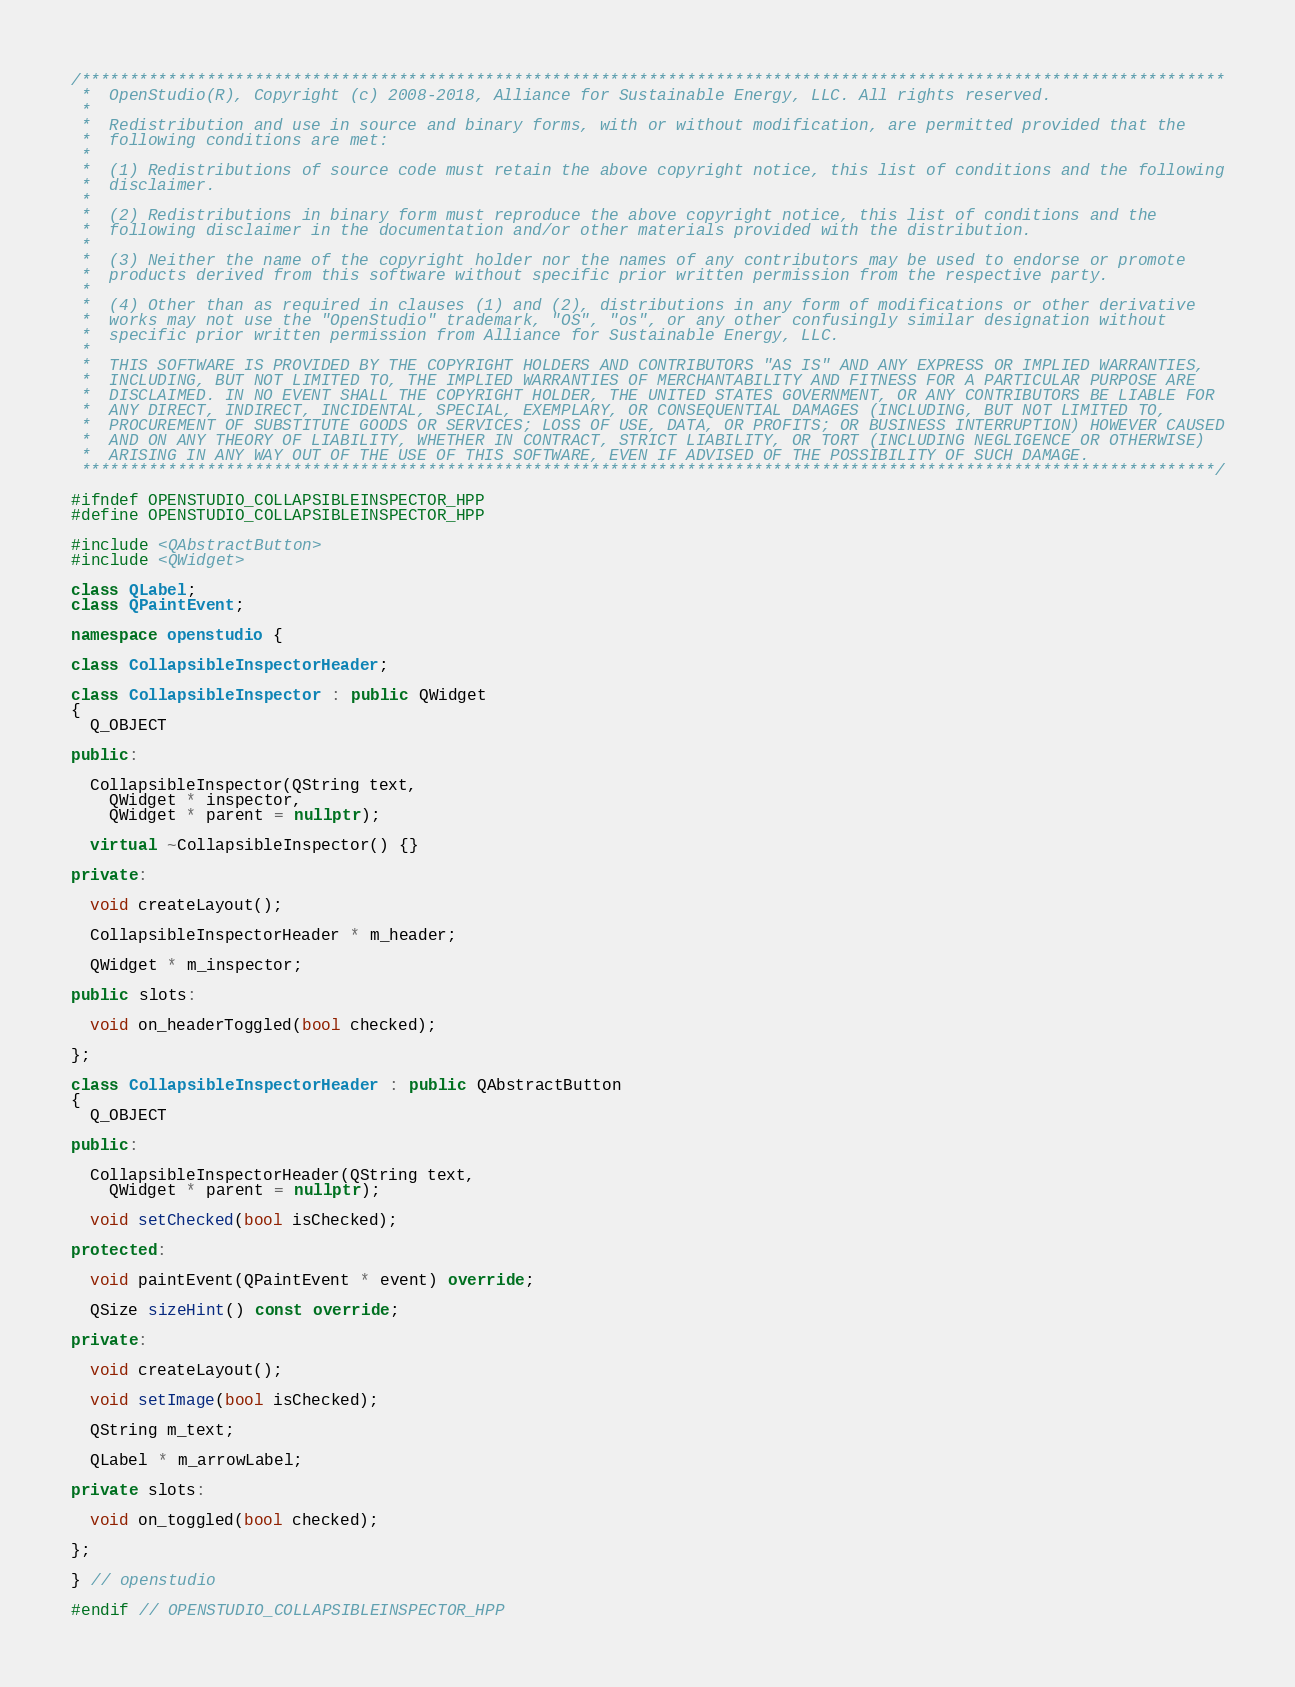<code> <loc_0><loc_0><loc_500><loc_500><_C++_>/***********************************************************************************************************************
 *  OpenStudio(R), Copyright (c) 2008-2018, Alliance for Sustainable Energy, LLC. All rights reserved.
 *
 *  Redistribution and use in source and binary forms, with or without modification, are permitted provided that the
 *  following conditions are met:
 *
 *  (1) Redistributions of source code must retain the above copyright notice, this list of conditions and the following
 *  disclaimer.
 *
 *  (2) Redistributions in binary form must reproduce the above copyright notice, this list of conditions and the
 *  following disclaimer in the documentation and/or other materials provided with the distribution.
 *
 *  (3) Neither the name of the copyright holder nor the names of any contributors may be used to endorse or promote
 *  products derived from this software without specific prior written permission from the respective party.
 *
 *  (4) Other than as required in clauses (1) and (2), distributions in any form of modifications or other derivative
 *  works may not use the "OpenStudio" trademark, "OS", "os", or any other confusingly similar designation without
 *  specific prior written permission from Alliance for Sustainable Energy, LLC.
 *
 *  THIS SOFTWARE IS PROVIDED BY THE COPYRIGHT HOLDERS AND CONTRIBUTORS "AS IS" AND ANY EXPRESS OR IMPLIED WARRANTIES,
 *  INCLUDING, BUT NOT LIMITED TO, THE IMPLIED WARRANTIES OF MERCHANTABILITY AND FITNESS FOR A PARTICULAR PURPOSE ARE
 *  DISCLAIMED. IN NO EVENT SHALL THE COPYRIGHT HOLDER, THE UNITED STATES GOVERNMENT, OR ANY CONTRIBUTORS BE LIABLE FOR
 *  ANY DIRECT, INDIRECT, INCIDENTAL, SPECIAL, EXEMPLARY, OR CONSEQUENTIAL DAMAGES (INCLUDING, BUT NOT LIMITED TO,
 *  PROCUREMENT OF SUBSTITUTE GOODS OR SERVICES; LOSS OF USE, DATA, OR PROFITS; OR BUSINESS INTERRUPTION) HOWEVER CAUSED
 *  AND ON ANY THEORY OF LIABILITY, WHETHER IN CONTRACT, STRICT LIABILITY, OR TORT (INCLUDING NEGLIGENCE OR OTHERWISE)
 *  ARISING IN ANY WAY OUT OF THE USE OF THIS SOFTWARE, EVEN IF ADVISED OF THE POSSIBILITY OF SUCH DAMAGE.
 **********************************************************************************************************************/

#ifndef OPENSTUDIO_COLLAPSIBLEINSPECTOR_HPP
#define OPENSTUDIO_COLLAPSIBLEINSPECTOR_HPP

#include <QAbstractButton>
#include <QWidget>

class QLabel;
class QPaintEvent;

namespace openstudio {

class CollapsibleInspectorHeader;

class CollapsibleInspector : public QWidget
{
  Q_OBJECT

public:

  CollapsibleInspector(QString text,
    QWidget * inspector,
    QWidget * parent = nullptr);

  virtual ~CollapsibleInspector() {}

private:

  void createLayout();

  CollapsibleInspectorHeader * m_header;

  QWidget * m_inspector;

public slots:

  void on_headerToggled(bool checked);

};

class CollapsibleInspectorHeader : public QAbstractButton
{
  Q_OBJECT

public:

  CollapsibleInspectorHeader(QString text,
    QWidget * parent = nullptr);

  void setChecked(bool isChecked);

protected:

  void paintEvent(QPaintEvent * event) override;

  QSize sizeHint() const override;

private:

  void createLayout();

  void setImage(bool isChecked);

  QString m_text;

  QLabel * m_arrowLabel;

private slots:

  void on_toggled(bool checked);

};

} // openstudio

#endif // OPENSTUDIO_COLLAPSIBLEINSPECTOR_HPP

</code> 